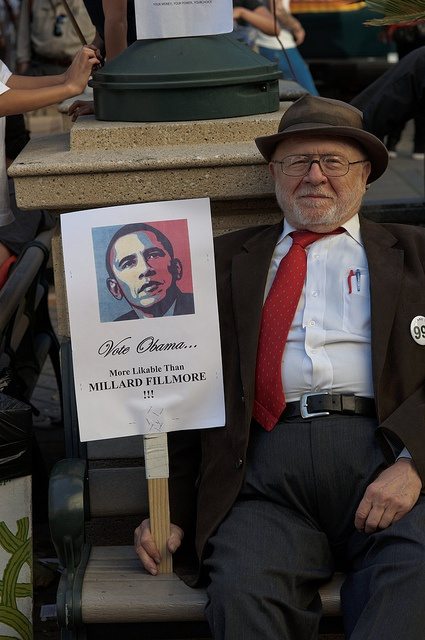Describe the objects in this image and their specific colors. I can see people in gray, black, maroon, and darkgray tones, bench in gray and black tones, people in gray, brown, darkgray, and black tones, tie in gray, maroon, brown, and black tones, and people in gray and black tones in this image. 